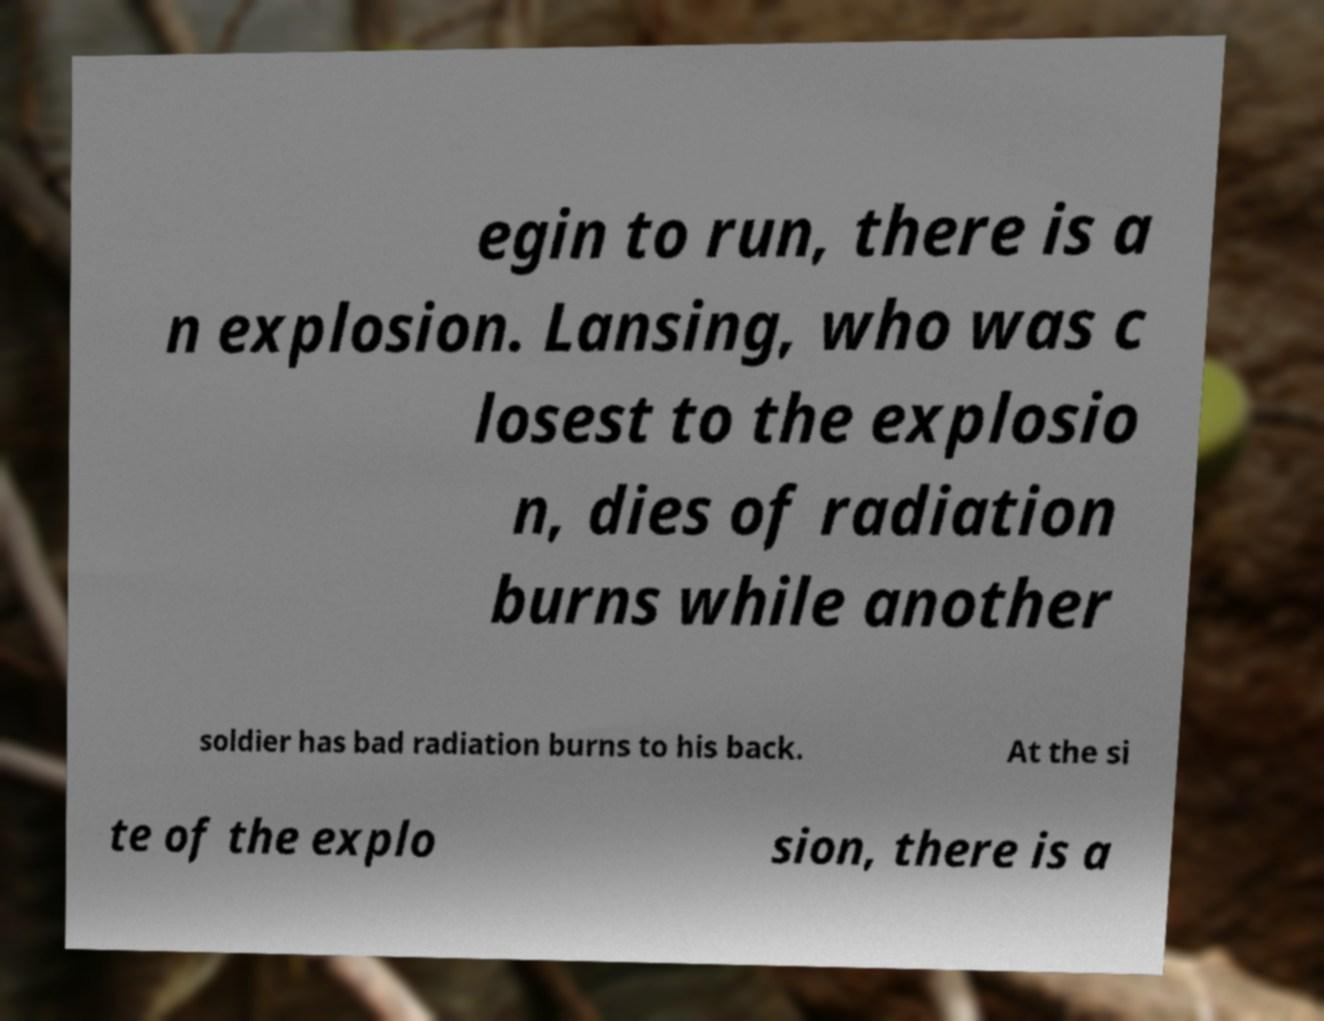There's text embedded in this image that I need extracted. Can you transcribe it verbatim? egin to run, there is a n explosion. Lansing, who was c losest to the explosio n, dies of radiation burns while another soldier has bad radiation burns to his back. At the si te of the explo sion, there is a 